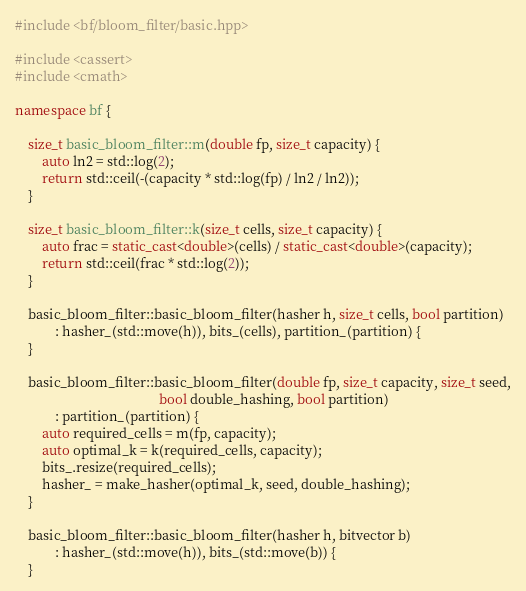<code> <loc_0><loc_0><loc_500><loc_500><_C++_>#include <bf/bloom_filter/basic.hpp>

#include <cassert>
#include <cmath>

namespace bf {

    size_t basic_bloom_filter::m(double fp, size_t capacity) {
        auto ln2 = std::log(2);
        return std::ceil(-(capacity * std::log(fp) / ln2 / ln2));
    }

    size_t basic_bloom_filter::k(size_t cells, size_t capacity) {
        auto frac = static_cast<double>(cells) / static_cast<double>(capacity);
        return std::ceil(frac * std::log(2));
    }

    basic_bloom_filter::basic_bloom_filter(hasher h, size_t cells, bool partition)
            : hasher_(std::move(h)), bits_(cells), partition_(partition) {
    }

    basic_bloom_filter::basic_bloom_filter(double fp, size_t capacity, size_t seed,
                                           bool double_hashing, bool partition)
            : partition_(partition) {
        auto required_cells = m(fp, capacity);
        auto optimal_k = k(required_cells, capacity);
        bits_.resize(required_cells);
        hasher_ = make_hasher(optimal_k, seed, double_hashing);
    }

    basic_bloom_filter::basic_bloom_filter(hasher h, bitvector b)
            : hasher_(std::move(h)), bits_(std::move(b)) {
    }
</code> 